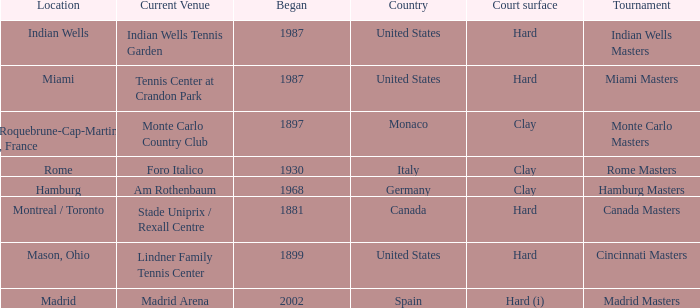What year was the tournament first held in Italy? 1930.0. 